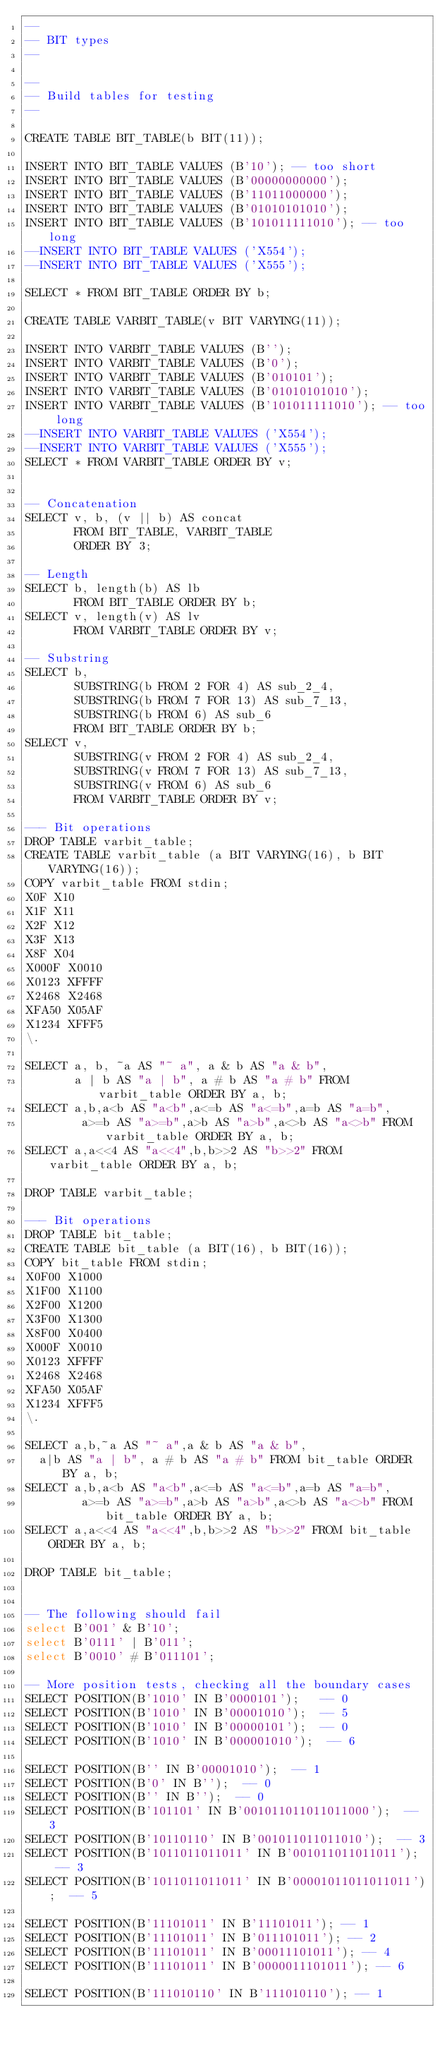Convert code to text. <code><loc_0><loc_0><loc_500><loc_500><_SQL_>--
-- BIT types
--

--
-- Build tables for testing
--

CREATE TABLE BIT_TABLE(b BIT(11));

INSERT INTO BIT_TABLE VALUES (B'10'); -- too short
INSERT INTO BIT_TABLE VALUES (B'00000000000');
INSERT INTO BIT_TABLE VALUES (B'11011000000');
INSERT INTO BIT_TABLE VALUES (B'01010101010');
INSERT INTO BIT_TABLE VALUES (B'101011111010'); -- too long
--INSERT INTO BIT_TABLE VALUES ('X554');
--INSERT INTO BIT_TABLE VALUES ('X555');

SELECT * FROM BIT_TABLE ORDER BY b;

CREATE TABLE VARBIT_TABLE(v BIT VARYING(11));

INSERT INTO VARBIT_TABLE VALUES (B'');
INSERT INTO VARBIT_TABLE VALUES (B'0');
INSERT INTO VARBIT_TABLE VALUES (B'010101');
INSERT INTO VARBIT_TABLE VALUES (B'01010101010');
INSERT INTO VARBIT_TABLE VALUES (B'101011111010'); -- too long
--INSERT INTO VARBIT_TABLE VALUES ('X554');
--INSERT INTO VARBIT_TABLE VALUES ('X555');
SELECT * FROM VARBIT_TABLE ORDER BY v;


-- Concatenation
SELECT v, b, (v || b) AS concat
       FROM BIT_TABLE, VARBIT_TABLE
       ORDER BY 3;

-- Length
SELECT b, length(b) AS lb
       FROM BIT_TABLE ORDER BY b;
SELECT v, length(v) AS lv
       FROM VARBIT_TABLE ORDER BY v;

-- Substring
SELECT b,
       SUBSTRING(b FROM 2 FOR 4) AS sub_2_4,
       SUBSTRING(b FROM 7 FOR 13) AS sub_7_13,
       SUBSTRING(b FROM 6) AS sub_6
       FROM BIT_TABLE ORDER BY b;
SELECT v,
       SUBSTRING(v FROM 2 FOR 4) AS sub_2_4,
       SUBSTRING(v FROM 7 FOR 13) AS sub_7_13,
       SUBSTRING(v FROM 6) AS sub_6
       FROM VARBIT_TABLE ORDER BY v;

--- Bit operations
DROP TABLE varbit_table;
CREATE TABLE varbit_table (a BIT VARYING(16), b BIT VARYING(16));
COPY varbit_table FROM stdin;
X0F	X10
X1F	X11
X2F	X12
X3F	X13
X8F	X04
X000F	X0010
X0123	XFFFF
X2468	X2468
XFA50	X05AF
X1234	XFFF5
\.

SELECT a, b, ~a AS "~ a", a & b AS "a & b",
       a | b AS "a | b", a # b AS "a # b" FROM varbit_table ORDER BY a, b;
SELECT a,b,a<b AS "a<b",a<=b AS "a<=b",a=b AS "a=b",
        a>=b AS "a>=b",a>b AS "a>b",a<>b AS "a<>b" FROM varbit_table ORDER BY a, b;
SELECT a,a<<4 AS "a<<4",b,b>>2 AS "b>>2" FROM varbit_table ORDER BY a, b;

DROP TABLE varbit_table;

--- Bit operations
DROP TABLE bit_table;
CREATE TABLE bit_table (a BIT(16), b BIT(16));
COPY bit_table FROM stdin;
X0F00	X1000
X1F00	X1100
X2F00	X1200
X3F00	X1300
X8F00	X0400
X000F	X0010
X0123	XFFFF
X2468	X2468
XFA50	X05AF
X1234	XFFF5
\.

SELECT a,b,~a AS "~ a",a & b AS "a & b",
	a|b AS "a | b", a # b AS "a # b" FROM bit_table ORDER BY a, b;
SELECT a,b,a<b AS "a<b",a<=b AS "a<=b",a=b AS "a=b",
        a>=b AS "a>=b",a>b AS "a>b",a<>b AS "a<>b" FROM bit_table ORDER BY a, b;
SELECT a,a<<4 AS "a<<4",b,b>>2 AS "b>>2" FROM bit_table ORDER BY a, b;

DROP TABLE bit_table;


-- The following should fail
select B'001' & B'10';
select B'0111' | B'011';
select B'0010' # B'011101';

-- More position tests, checking all the boundary cases
SELECT POSITION(B'1010' IN B'0000101');   -- 0
SELECT POSITION(B'1010' IN B'00001010');  -- 5
SELECT POSITION(B'1010' IN B'00000101');  -- 0
SELECT POSITION(B'1010' IN B'000001010');  -- 6

SELECT POSITION(B'' IN B'00001010');  -- 1
SELECT POSITION(B'0' IN B'');  -- 0
SELECT POSITION(B'' IN B'');  -- 0
SELECT POSITION(B'101101' IN B'001011011011011000');  -- 3
SELECT POSITION(B'10110110' IN B'001011011011010');  -- 3
SELECT POSITION(B'1011011011011' IN B'001011011011011');  -- 3
SELECT POSITION(B'1011011011011' IN B'00001011011011011');  -- 5

SELECT POSITION(B'11101011' IN B'11101011'); -- 1
SELECT POSITION(B'11101011' IN B'011101011'); -- 2
SELECT POSITION(B'11101011' IN B'00011101011'); -- 4
SELECT POSITION(B'11101011' IN B'0000011101011'); -- 6

SELECT POSITION(B'111010110' IN B'111010110'); -- 1</code> 